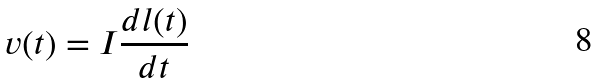<formula> <loc_0><loc_0><loc_500><loc_500>v ( t ) = I \frac { d l ( t ) } { d t }</formula> 